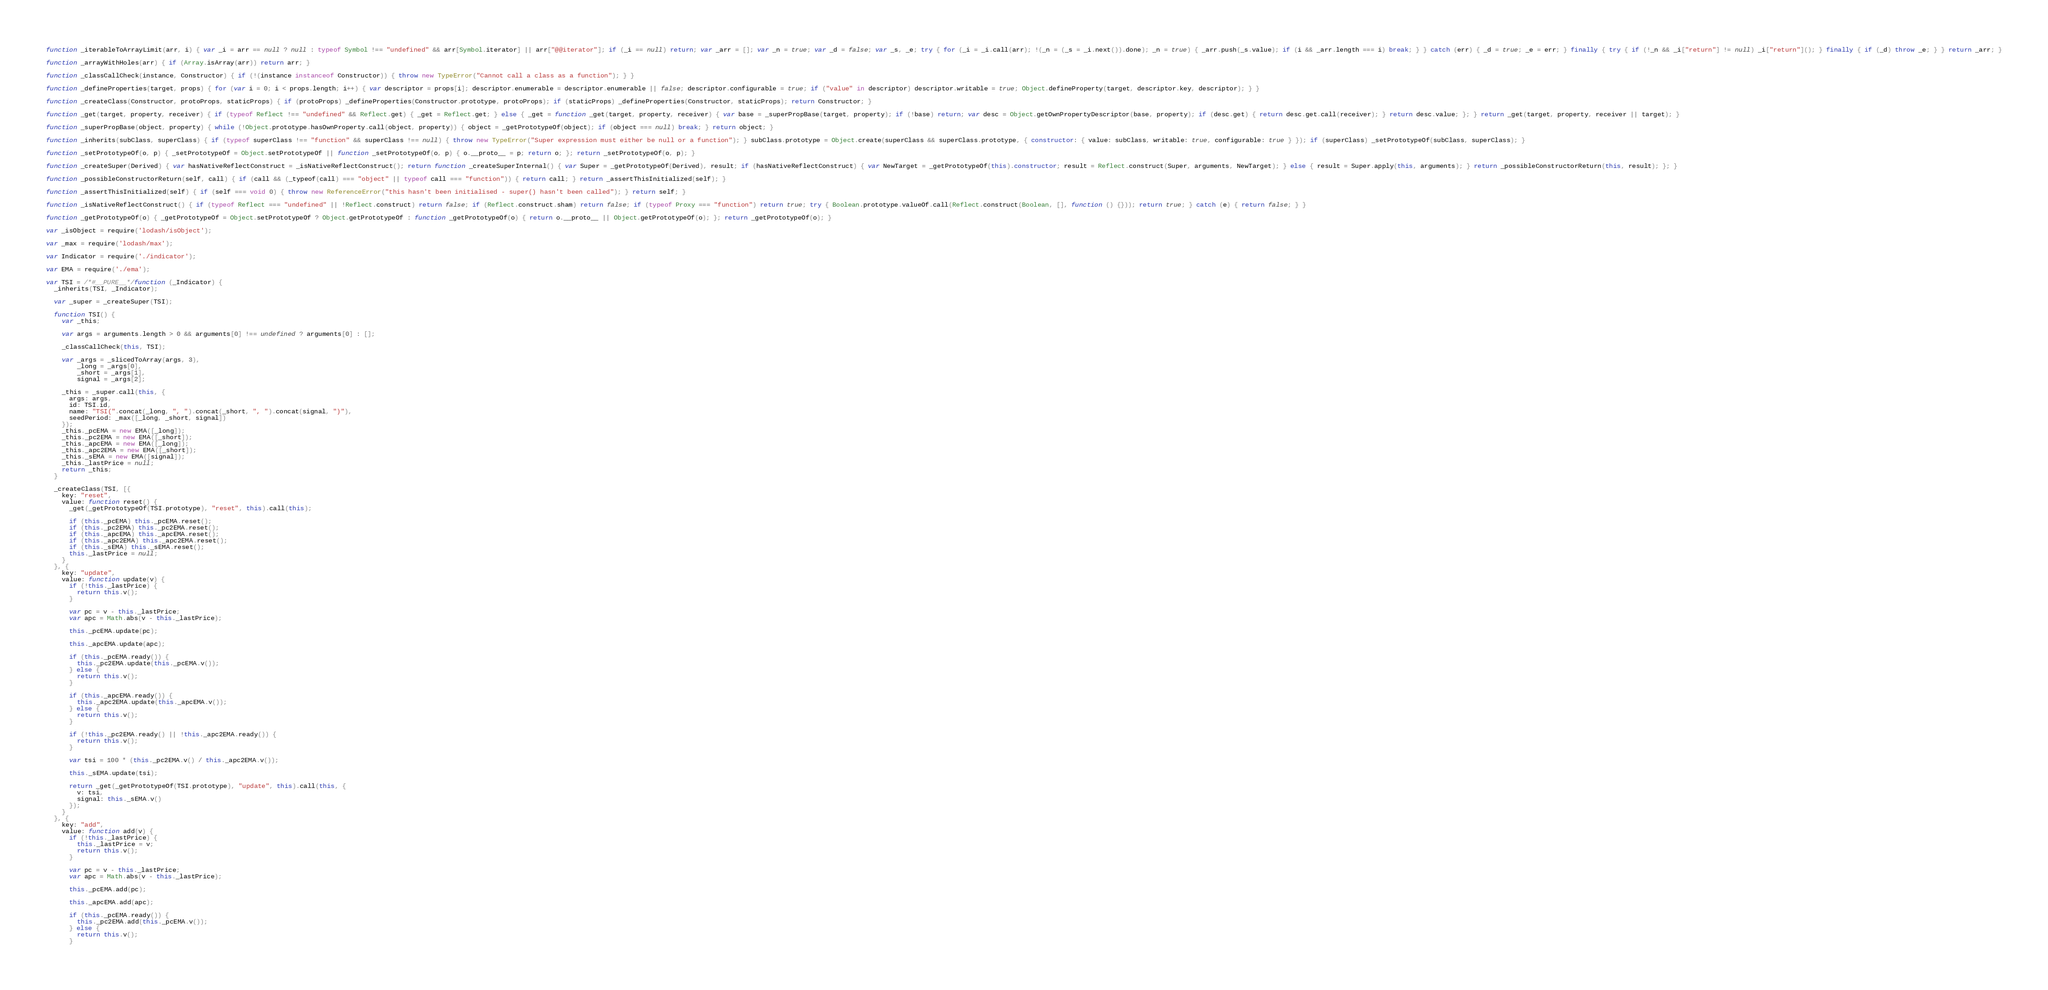Convert code to text. <code><loc_0><loc_0><loc_500><loc_500><_JavaScript_>
function _iterableToArrayLimit(arr, i) { var _i = arr == null ? null : typeof Symbol !== "undefined" && arr[Symbol.iterator] || arr["@@iterator"]; if (_i == null) return; var _arr = []; var _n = true; var _d = false; var _s, _e; try { for (_i = _i.call(arr); !(_n = (_s = _i.next()).done); _n = true) { _arr.push(_s.value); if (i && _arr.length === i) break; } } catch (err) { _d = true; _e = err; } finally { try { if (!_n && _i["return"] != null) _i["return"](); } finally { if (_d) throw _e; } } return _arr; }

function _arrayWithHoles(arr) { if (Array.isArray(arr)) return arr; }

function _classCallCheck(instance, Constructor) { if (!(instance instanceof Constructor)) { throw new TypeError("Cannot call a class as a function"); } }

function _defineProperties(target, props) { for (var i = 0; i < props.length; i++) { var descriptor = props[i]; descriptor.enumerable = descriptor.enumerable || false; descriptor.configurable = true; if ("value" in descriptor) descriptor.writable = true; Object.defineProperty(target, descriptor.key, descriptor); } }

function _createClass(Constructor, protoProps, staticProps) { if (protoProps) _defineProperties(Constructor.prototype, protoProps); if (staticProps) _defineProperties(Constructor, staticProps); return Constructor; }

function _get(target, property, receiver) { if (typeof Reflect !== "undefined" && Reflect.get) { _get = Reflect.get; } else { _get = function _get(target, property, receiver) { var base = _superPropBase(target, property); if (!base) return; var desc = Object.getOwnPropertyDescriptor(base, property); if (desc.get) { return desc.get.call(receiver); } return desc.value; }; } return _get(target, property, receiver || target); }

function _superPropBase(object, property) { while (!Object.prototype.hasOwnProperty.call(object, property)) { object = _getPrototypeOf(object); if (object === null) break; } return object; }

function _inherits(subClass, superClass) { if (typeof superClass !== "function" && superClass !== null) { throw new TypeError("Super expression must either be null or a function"); } subClass.prototype = Object.create(superClass && superClass.prototype, { constructor: { value: subClass, writable: true, configurable: true } }); if (superClass) _setPrototypeOf(subClass, superClass); }

function _setPrototypeOf(o, p) { _setPrototypeOf = Object.setPrototypeOf || function _setPrototypeOf(o, p) { o.__proto__ = p; return o; }; return _setPrototypeOf(o, p); }

function _createSuper(Derived) { var hasNativeReflectConstruct = _isNativeReflectConstruct(); return function _createSuperInternal() { var Super = _getPrototypeOf(Derived), result; if (hasNativeReflectConstruct) { var NewTarget = _getPrototypeOf(this).constructor; result = Reflect.construct(Super, arguments, NewTarget); } else { result = Super.apply(this, arguments); } return _possibleConstructorReturn(this, result); }; }

function _possibleConstructorReturn(self, call) { if (call && (_typeof(call) === "object" || typeof call === "function")) { return call; } return _assertThisInitialized(self); }

function _assertThisInitialized(self) { if (self === void 0) { throw new ReferenceError("this hasn't been initialised - super() hasn't been called"); } return self; }

function _isNativeReflectConstruct() { if (typeof Reflect === "undefined" || !Reflect.construct) return false; if (Reflect.construct.sham) return false; if (typeof Proxy === "function") return true; try { Boolean.prototype.valueOf.call(Reflect.construct(Boolean, [], function () {})); return true; } catch (e) { return false; } }

function _getPrototypeOf(o) { _getPrototypeOf = Object.setPrototypeOf ? Object.getPrototypeOf : function _getPrototypeOf(o) { return o.__proto__ || Object.getPrototypeOf(o); }; return _getPrototypeOf(o); }

var _isObject = require('lodash/isObject');

var _max = require('lodash/max');

var Indicator = require('./indicator');

var EMA = require('./ema');

var TSI = /*#__PURE__*/function (_Indicator) {
  _inherits(TSI, _Indicator);

  var _super = _createSuper(TSI);

  function TSI() {
    var _this;

    var args = arguments.length > 0 && arguments[0] !== undefined ? arguments[0] : [];

    _classCallCheck(this, TSI);

    var _args = _slicedToArray(args, 3),
        _long = _args[0],
        _short = _args[1],
        signal = _args[2];

    _this = _super.call(this, {
      args: args,
      id: TSI.id,
      name: "TSI(".concat(_long, ", ").concat(_short, ", ").concat(signal, ")"),
      seedPeriod: _max([_long, _short, signal])
    });
    _this._pcEMA = new EMA([_long]);
    _this._pc2EMA = new EMA([_short]);
    _this._apcEMA = new EMA([_long]);
    _this._apc2EMA = new EMA([_short]);
    _this._sEMA = new EMA([signal]);
    _this._lastPrice = null;
    return _this;
  }

  _createClass(TSI, [{
    key: "reset",
    value: function reset() {
      _get(_getPrototypeOf(TSI.prototype), "reset", this).call(this);

      if (this._pcEMA) this._pcEMA.reset();
      if (this._pc2EMA) this._pc2EMA.reset();
      if (this._apcEMA) this._apcEMA.reset();
      if (this._apc2EMA) this._apc2EMA.reset();
      if (this._sEMA) this._sEMA.reset();
      this._lastPrice = null;
    }
  }, {
    key: "update",
    value: function update(v) {
      if (!this._lastPrice) {
        return this.v();
      }

      var pc = v - this._lastPrice;
      var apc = Math.abs(v - this._lastPrice);

      this._pcEMA.update(pc);

      this._apcEMA.update(apc);

      if (this._pcEMA.ready()) {
        this._pc2EMA.update(this._pcEMA.v());
      } else {
        return this.v();
      }

      if (this._apcEMA.ready()) {
        this._apc2EMA.update(this._apcEMA.v());
      } else {
        return this.v();
      }

      if (!this._pc2EMA.ready() || !this._apc2EMA.ready()) {
        return this.v();
      }

      var tsi = 100 * (this._pc2EMA.v() / this._apc2EMA.v());

      this._sEMA.update(tsi);

      return _get(_getPrototypeOf(TSI.prototype), "update", this).call(this, {
        v: tsi,
        signal: this._sEMA.v()
      });
    }
  }, {
    key: "add",
    value: function add(v) {
      if (!this._lastPrice) {
        this._lastPrice = v;
        return this.v();
      }

      var pc = v - this._lastPrice;
      var apc = Math.abs(v - this._lastPrice);

      this._pcEMA.add(pc);

      this._apcEMA.add(apc);

      if (this._pcEMA.ready()) {
        this._pc2EMA.add(this._pcEMA.v());
      } else {
        return this.v();
      }
</code> 